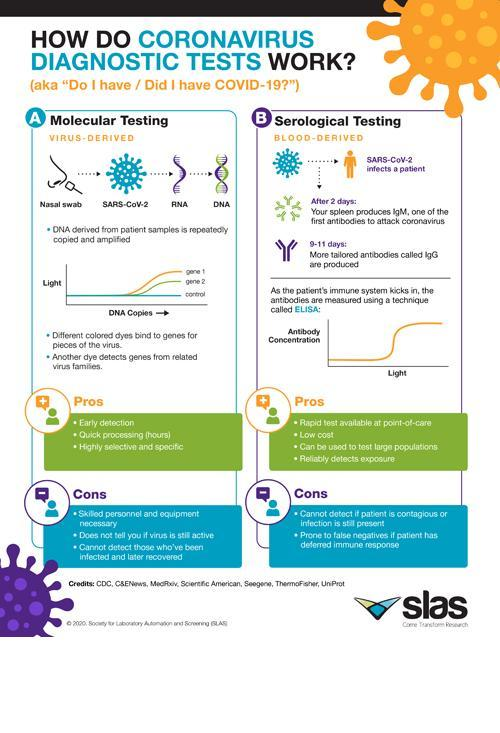How many pros are for molecular testing?
Answer the question with a short phrase. 3 What is the base of serological testing-virus, blood? blood How many cons are for serological testing? 2 What is the base of molecular testing-virus, blood? virus After how many days spleen produce IgM? 2 